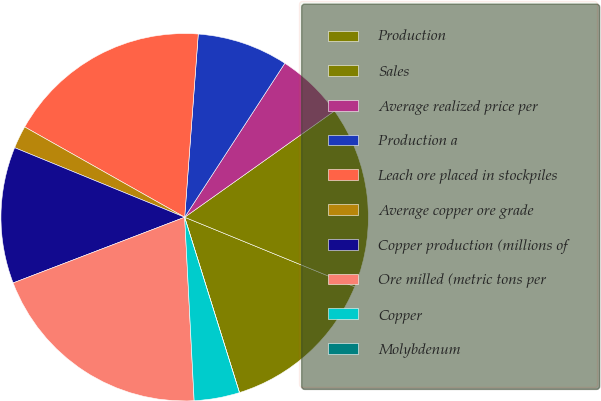Convert chart to OTSL. <chart><loc_0><loc_0><loc_500><loc_500><pie_chart><fcel>Production<fcel>Sales<fcel>Average realized price per<fcel>Production a<fcel>Leach ore placed in stockpiles<fcel>Average copper ore grade<fcel>Copper production (millions of<fcel>Ore milled (metric tons per<fcel>Copper<fcel>Molybdenum<nl><fcel>14.0%<fcel>16.0%<fcel>6.0%<fcel>8.0%<fcel>18.0%<fcel>2.0%<fcel>12.0%<fcel>20.0%<fcel>4.0%<fcel>0.0%<nl></chart> 